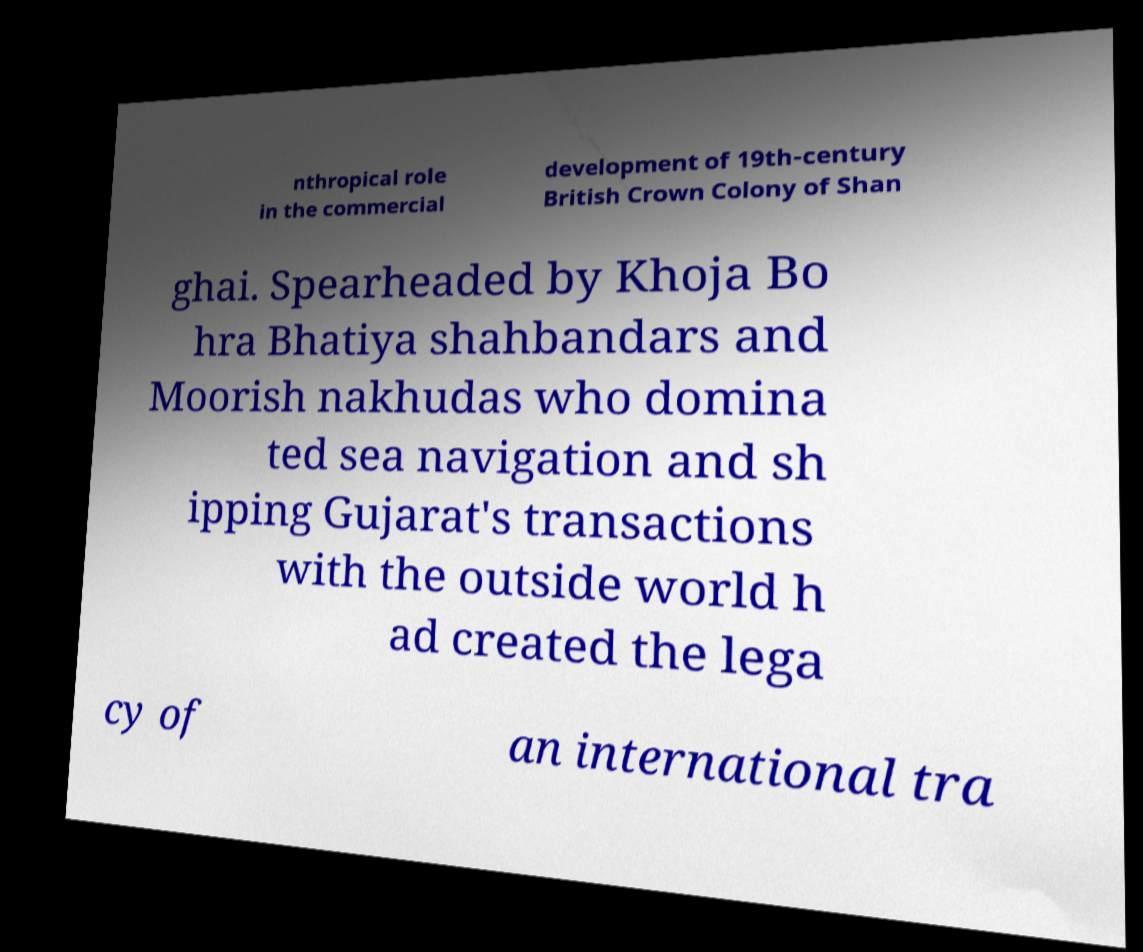Can you read and provide the text displayed in the image?This photo seems to have some interesting text. Can you extract and type it out for me? nthropical role in the commercial development of 19th-century British Crown Colony of Shan ghai. Spearheaded by Khoja Bo hra Bhatiya shahbandars and Moorish nakhudas who domina ted sea navigation and sh ipping Gujarat's transactions with the outside world h ad created the lega cy of an international tra 